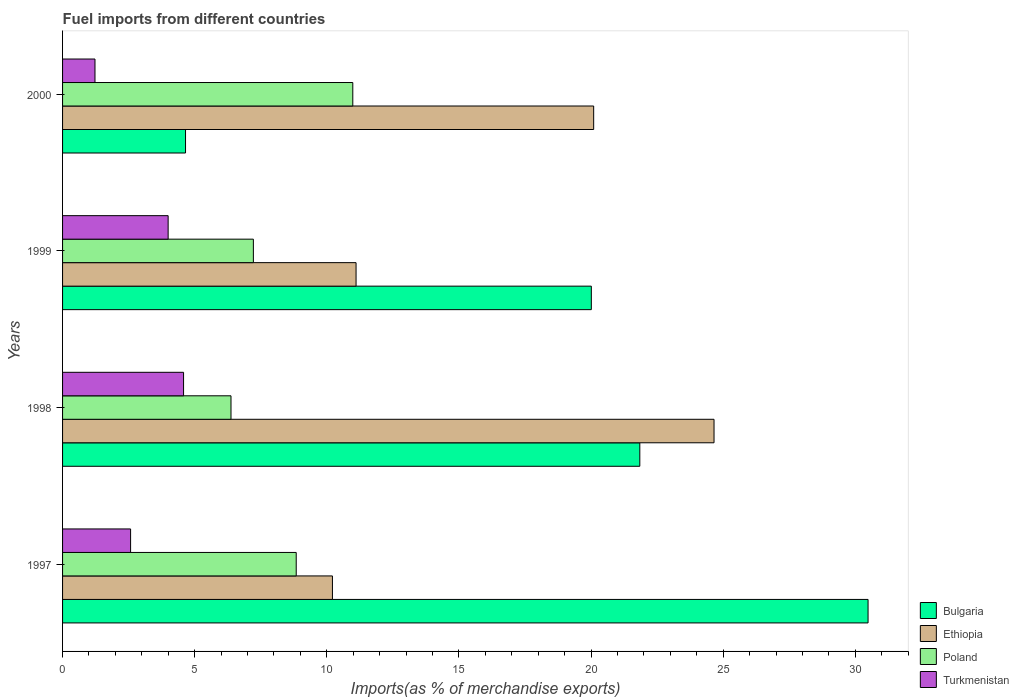How many different coloured bars are there?
Keep it short and to the point. 4. Are the number of bars on each tick of the Y-axis equal?
Offer a terse response. Yes. What is the label of the 3rd group of bars from the top?
Your answer should be compact. 1998. In how many cases, is the number of bars for a given year not equal to the number of legend labels?
Offer a terse response. 0. What is the percentage of imports to different countries in Bulgaria in 2000?
Your answer should be very brief. 4.65. Across all years, what is the maximum percentage of imports to different countries in Bulgaria?
Your answer should be compact. 30.48. Across all years, what is the minimum percentage of imports to different countries in Poland?
Provide a succinct answer. 6.37. In which year was the percentage of imports to different countries in Turkmenistan maximum?
Keep it short and to the point. 1998. What is the total percentage of imports to different countries in Poland in the graph?
Provide a short and direct response. 33.42. What is the difference between the percentage of imports to different countries in Bulgaria in 1997 and that in 1999?
Make the answer very short. 10.47. What is the difference between the percentage of imports to different countries in Ethiopia in 2000 and the percentage of imports to different countries in Poland in 1998?
Keep it short and to the point. 13.73. What is the average percentage of imports to different countries in Bulgaria per year?
Your response must be concise. 19.25. In the year 1999, what is the difference between the percentage of imports to different countries in Bulgaria and percentage of imports to different countries in Ethiopia?
Provide a succinct answer. 8.9. In how many years, is the percentage of imports to different countries in Turkmenistan greater than 18 %?
Provide a succinct answer. 0. What is the ratio of the percentage of imports to different countries in Ethiopia in 1998 to that in 1999?
Provide a succinct answer. 2.22. Is the percentage of imports to different countries in Poland in 1997 less than that in 2000?
Your answer should be compact. Yes. Is the difference between the percentage of imports to different countries in Bulgaria in 1997 and 2000 greater than the difference between the percentage of imports to different countries in Ethiopia in 1997 and 2000?
Give a very brief answer. Yes. What is the difference between the highest and the second highest percentage of imports to different countries in Ethiopia?
Your response must be concise. 4.55. What is the difference between the highest and the lowest percentage of imports to different countries in Bulgaria?
Offer a very short reply. 25.83. Is the sum of the percentage of imports to different countries in Ethiopia in 1997 and 1998 greater than the maximum percentage of imports to different countries in Turkmenistan across all years?
Ensure brevity in your answer.  Yes. Is it the case that in every year, the sum of the percentage of imports to different countries in Ethiopia and percentage of imports to different countries in Bulgaria is greater than the sum of percentage of imports to different countries in Turkmenistan and percentage of imports to different countries in Poland?
Offer a terse response. No. What does the 3rd bar from the top in 1998 represents?
Keep it short and to the point. Ethiopia. What does the 2nd bar from the bottom in 1997 represents?
Provide a short and direct response. Ethiopia. How many bars are there?
Provide a succinct answer. 16. Are all the bars in the graph horizontal?
Keep it short and to the point. Yes. How many years are there in the graph?
Your answer should be compact. 4. What is the difference between two consecutive major ticks on the X-axis?
Your response must be concise. 5. Are the values on the major ticks of X-axis written in scientific E-notation?
Your answer should be compact. No. Where does the legend appear in the graph?
Ensure brevity in your answer.  Bottom right. What is the title of the graph?
Your answer should be very brief. Fuel imports from different countries. What is the label or title of the X-axis?
Provide a succinct answer. Imports(as % of merchandise exports). What is the Imports(as % of merchandise exports) of Bulgaria in 1997?
Keep it short and to the point. 30.48. What is the Imports(as % of merchandise exports) in Ethiopia in 1997?
Keep it short and to the point. 10.21. What is the Imports(as % of merchandise exports) of Poland in 1997?
Provide a succinct answer. 8.84. What is the Imports(as % of merchandise exports) in Turkmenistan in 1997?
Your answer should be very brief. 2.57. What is the Imports(as % of merchandise exports) of Bulgaria in 1998?
Your answer should be very brief. 21.85. What is the Imports(as % of merchandise exports) of Ethiopia in 1998?
Give a very brief answer. 24.65. What is the Imports(as % of merchandise exports) in Poland in 1998?
Your response must be concise. 6.37. What is the Imports(as % of merchandise exports) of Turkmenistan in 1998?
Keep it short and to the point. 4.58. What is the Imports(as % of merchandise exports) in Bulgaria in 1999?
Your answer should be very brief. 20.01. What is the Imports(as % of merchandise exports) of Ethiopia in 1999?
Your answer should be very brief. 11.11. What is the Imports(as % of merchandise exports) of Poland in 1999?
Provide a succinct answer. 7.22. What is the Imports(as % of merchandise exports) in Turkmenistan in 1999?
Provide a succinct answer. 4. What is the Imports(as % of merchandise exports) in Bulgaria in 2000?
Provide a succinct answer. 4.65. What is the Imports(as % of merchandise exports) of Ethiopia in 2000?
Give a very brief answer. 20.1. What is the Imports(as % of merchandise exports) of Poland in 2000?
Your answer should be very brief. 10.98. What is the Imports(as % of merchandise exports) in Turkmenistan in 2000?
Keep it short and to the point. 1.23. Across all years, what is the maximum Imports(as % of merchandise exports) in Bulgaria?
Your answer should be very brief. 30.48. Across all years, what is the maximum Imports(as % of merchandise exports) of Ethiopia?
Provide a short and direct response. 24.65. Across all years, what is the maximum Imports(as % of merchandise exports) of Poland?
Provide a short and direct response. 10.98. Across all years, what is the maximum Imports(as % of merchandise exports) of Turkmenistan?
Your response must be concise. 4.58. Across all years, what is the minimum Imports(as % of merchandise exports) in Bulgaria?
Ensure brevity in your answer.  4.65. Across all years, what is the minimum Imports(as % of merchandise exports) of Ethiopia?
Provide a short and direct response. 10.21. Across all years, what is the minimum Imports(as % of merchandise exports) of Poland?
Give a very brief answer. 6.37. Across all years, what is the minimum Imports(as % of merchandise exports) in Turkmenistan?
Ensure brevity in your answer.  1.23. What is the total Imports(as % of merchandise exports) in Bulgaria in the graph?
Offer a very short reply. 76.99. What is the total Imports(as % of merchandise exports) in Ethiopia in the graph?
Give a very brief answer. 66.07. What is the total Imports(as % of merchandise exports) of Poland in the graph?
Keep it short and to the point. 33.42. What is the total Imports(as % of merchandise exports) of Turkmenistan in the graph?
Provide a succinct answer. 12.38. What is the difference between the Imports(as % of merchandise exports) of Bulgaria in 1997 and that in 1998?
Provide a succinct answer. 8.64. What is the difference between the Imports(as % of merchandise exports) of Ethiopia in 1997 and that in 1998?
Ensure brevity in your answer.  -14.44. What is the difference between the Imports(as % of merchandise exports) of Poland in 1997 and that in 1998?
Your answer should be compact. 2.47. What is the difference between the Imports(as % of merchandise exports) in Turkmenistan in 1997 and that in 1998?
Ensure brevity in your answer.  -2. What is the difference between the Imports(as % of merchandise exports) in Bulgaria in 1997 and that in 1999?
Give a very brief answer. 10.47. What is the difference between the Imports(as % of merchandise exports) of Ethiopia in 1997 and that in 1999?
Your answer should be compact. -0.89. What is the difference between the Imports(as % of merchandise exports) of Poland in 1997 and that in 1999?
Your response must be concise. 1.62. What is the difference between the Imports(as % of merchandise exports) in Turkmenistan in 1997 and that in 1999?
Offer a terse response. -1.42. What is the difference between the Imports(as % of merchandise exports) in Bulgaria in 1997 and that in 2000?
Offer a terse response. 25.83. What is the difference between the Imports(as % of merchandise exports) of Ethiopia in 1997 and that in 2000?
Offer a terse response. -9.89. What is the difference between the Imports(as % of merchandise exports) of Poland in 1997 and that in 2000?
Your response must be concise. -2.14. What is the difference between the Imports(as % of merchandise exports) in Turkmenistan in 1997 and that in 2000?
Offer a terse response. 1.35. What is the difference between the Imports(as % of merchandise exports) in Bulgaria in 1998 and that in 1999?
Your answer should be compact. 1.83. What is the difference between the Imports(as % of merchandise exports) of Ethiopia in 1998 and that in 1999?
Your answer should be compact. 13.55. What is the difference between the Imports(as % of merchandise exports) in Poland in 1998 and that in 1999?
Your answer should be very brief. -0.85. What is the difference between the Imports(as % of merchandise exports) in Turkmenistan in 1998 and that in 1999?
Keep it short and to the point. 0.58. What is the difference between the Imports(as % of merchandise exports) in Bulgaria in 1998 and that in 2000?
Give a very brief answer. 17.19. What is the difference between the Imports(as % of merchandise exports) of Ethiopia in 1998 and that in 2000?
Offer a terse response. 4.55. What is the difference between the Imports(as % of merchandise exports) in Poland in 1998 and that in 2000?
Offer a very short reply. -4.61. What is the difference between the Imports(as % of merchandise exports) of Turkmenistan in 1998 and that in 2000?
Offer a very short reply. 3.35. What is the difference between the Imports(as % of merchandise exports) in Bulgaria in 1999 and that in 2000?
Your answer should be compact. 15.36. What is the difference between the Imports(as % of merchandise exports) in Ethiopia in 1999 and that in 2000?
Provide a short and direct response. -8.99. What is the difference between the Imports(as % of merchandise exports) of Poland in 1999 and that in 2000?
Your answer should be very brief. -3.76. What is the difference between the Imports(as % of merchandise exports) of Turkmenistan in 1999 and that in 2000?
Keep it short and to the point. 2.77. What is the difference between the Imports(as % of merchandise exports) of Bulgaria in 1997 and the Imports(as % of merchandise exports) of Ethiopia in 1998?
Ensure brevity in your answer.  5.83. What is the difference between the Imports(as % of merchandise exports) of Bulgaria in 1997 and the Imports(as % of merchandise exports) of Poland in 1998?
Keep it short and to the point. 24.11. What is the difference between the Imports(as % of merchandise exports) in Bulgaria in 1997 and the Imports(as % of merchandise exports) in Turkmenistan in 1998?
Offer a very short reply. 25.9. What is the difference between the Imports(as % of merchandise exports) in Ethiopia in 1997 and the Imports(as % of merchandise exports) in Poland in 1998?
Give a very brief answer. 3.84. What is the difference between the Imports(as % of merchandise exports) in Ethiopia in 1997 and the Imports(as % of merchandise exports) in Turkmenistan in 1998?
Your response must be concise. 5.63. What is the difference between the Imports(as % of merchandise exports) in Poland in 1997 and the Imports(as % of merchandise exports) in Turkmenistan in 1998?
Give a very brief answer. 4.26. What is the difference between the Imports(as % of merchandise exports) in Bulgaria in 1997 and the Imports(as % of merchandise exports) in Ethiopia in 1999?
Provide a succinct answer. 19.38. What is the difference between the Imports(as % of merchandise exports) of Bulgaria in 1997 and the Imports(as % of merchandise exports) of Poland in 1999?
Provide a succinct answer. 23.26. What is the difference between the Imports(as % of merchandise exports) of Bulgaria in 1997 and the Imports(as % of merchandise exports) of Turkmenistan in 1999?
Offer a terse response. 26.49. What is the difference between the Imports(as % of merchandise exports) in Ethiopia in 1997 and the Imports(as % of merchandise exports) in Poland in 1999?
Offer a very short reply. 2.99. What is the difference between the Imports(as % of merchandise exports) in Ethiopia in 1997 and the Imports(as % of merchandise exports) in Turkmenistan in 1999?
Keep it short and to the point. 6.22. What is the difference between the Imports(as % of merchandise exports) of Poland in 1997 and the Imports(as % of merchandise exports) of Turkmenistan in 1999?
Offer a terse response. 4.85. What is the difference between the Imports(as % of merchandise exports) in Bulgaria in 1997 and the Imports(as % of merchandise exports) in Ethiopia in 2000?
Your answer should be very brief. 10.38. What is the difference between the Imports(as % of merchandise exports) in Bulgaria in 1997 and the Imports(as % of merchandise exports) in Poland in 2000?
Offer a very short reply. 19.5. What is the difference between the Imports(as % of merchandise exports) of Bulgaria in 1997 and the Imports(as % of merchandise exports) of Turkmenistan in 2000?
Your answer should be very brief. 29.26. What is the difference between the Imports(as % of merchandise exports) of Ethiopia in 1997 and the Imports(as % of merchandise exports) of Poland in 2000?
Ensure brevity in your answer.  -0.77. What is the difference between the Imports(as % of merchandise exports) in Ethiopia in 1997 and the Imports(as % of merchandise exports) in Turkmenistan in 2000?
Keep it short and to the point. 8.99. What is the difference between the Imports(as % of merchandise exports) of Poland in 1997 and the Imports(as % of merchandise exports) of Turkmenistan in 2000?
Offer a very short reply. 7.62. What is the difference between the Imports(as % of merchandise exports) in Bulgaria in 1998 and the Imports(as % of merchandise exports) in Ethiopia in 1999?
Keep it short and to the point. 10.74. What is the difference between the Imports(as % of merchandise exports) of Bulgaria in 1998 and the Imports(as % of merchandise exports) of Poland in 1999?
Your response must be concise. 14.62. What is the difference between the Imports(as % of merchandise exports) of Bulgaria in 1998 and the Imports(as % of merchandise exports) of Turkmenistan in 1999?
Provide a short and direct response. 17.85. What is the difference between the Imports(as % of merchandise exports) of Ethiopia in 1998 and the Imports(as % of merchandise exports) of Poland in 1999?
Offer a very short reply. 17.43. What is the difference between the Imports(as % of merchandise exports) in Ethiopia in 1998 and the Imports(as % of merchandise exports) in Turkmenistan in 1999?
Provide a succinct answer. 20.66. What is the difference between the Imports(as % of merchandise exports) of Poland in 1998 and the Imports(as % of merchandise exports) of Turkmenistan in 1999?
Your answer should be very brief. 2.38. What is the difference between the Imports(as % of merchandise exports) in Bulgaria in 1998 and the Imports(as % of merchandise exports) in Ethiopia in 2000?
Your response must be concise. 1.75. What is the difference between the Imports(as % of merchandise exports) of Bulgaria in 1998 and the Imports(as % of merchandise exports) of Poland in 2000?
Keep it short and to the point. 10.86. What is the difference between the Imports(as % of merchandise exports) in Bulgaria in 1998 and the Imports(as % of merchandise exports) in Turkmenistan in 2000?
Your answer should be very brief. 20.62. What is the difference between the Imports(as % of merchandise exports) in Ethiopia in 1998 and the Imports(as % of merchandise exports) in Poland in 2000?
Offer a very short reply. 13.67. What is the difference between the Imports(as % of merchandise exports) in Ethiopia in 1998 and the Imports(as % of merchandise exports) in Turkmenistan in 2000?
Offer a terse response. 23.43. What is the difference between the Imports(as % of merchandise exports) in Poland in 1998 and the Imports(as % of merchandise exports) in Turkmenistan in 2000?
Your answer should be compact. 5.15. What is the difference between the Imports(as % of merchandise exports) of Bulgaria in 1999 and the Imports(as % of merchandise exports) of Ethiopia in 2000?
Make the answer very short. -0.09. What is the difference between the Imports(as % of merchandise exports) in Bulgaria in 1999 and the Imports(as % of merchandise exports) in Poland in 2000?
Your answer should be compact. 9.03. What is the difference between the Imports(as % of merchandise exports) in Bulgaria in 1999 and the Imports(as % of merchandise exports) in Turkmenistan in 2000?
Make the answer very short. 18.78. What is the difference between the Imports(as % of merchandise exports) in Ethiopia in 1999 and the Imports(as % of merchandise exports) in Poland in 2000?
Your response must be concise. 0.12. What is the difference between the Imports(as % of merchandise exports) in Ethiopia in 1999 and the Imports(as % of merchandise exports) in Turkmenistan in 2000?
Make the answer very short. 9.88. What is the difference between the Imports(as % of merchandise exports) of Poland in 1999 and the Imports(as % of merchandise exports) of Turkmenistan in 2000?
Your answer should be compact. 5.99. What is the average Imports(as % of merchandise exports) in Bulgaria per year?
Offer a very short reply. 19.25. What is the average Imports(as % of merchandise exports) in Ethiopia per year?
Provide a succinct answer. 16.52. What is the average Imports(as % of merchandise exports) in Poland per year?
Provide a succinct answer. 8.36. What is the average Imports(as % of merchandise exports) of Turkmenistan per year?
Provide a succinct answer. 3.09. In the year 1997, what is the difference between the Imports(as % of merchandise exports) of Bulgaria and Imports(as % of merchandise exports) of Ethiopia?
Make the answer very short. 20.27. In the year 1997, what is the difference between the Imports(as % of merchandise exports) of Bulgaria and Imports(as % of merchandise exports) of Poland?
Ensure brevity in your answer.  21.64. In the year 1997, what is the difference between the Imports(as % of merchandise exports) of Bulgaria and Imports(as % of merchandise exports) of Turkmenistan?
Provide a short and direct response. 27.91. In the year 1997, what is the difference between the Imports(as % of merchandise exports) in Ethiopia and Imports(as % of merchandise exports) in Poland?
Provide a succinct answer. 1.37. In the year 1997, what is the difference between the Imports(as % of merchandise exports) in Ethiopia and Imports(as % of merchandise exports) in Turkmenistan?
Provide a succinct answer. 7.64. In the year 1997, what is the difference between the Imports(as % of merchandise exports) in Poland and Imports(as % of merchandise exports) in Turkmenistan?
Your answer should be very brief. 6.27. In the year 1998, what is the difference between the Imports(as % of merchandise exports) of Bulgaria and Imports(as % of merchandise exports) of Ethiopia?
Offer a very short reply. -2.81. In the year 1998, what is the difference between the Imports(as % of merchandise exports) of Bulgaria and Imports(as % of merchandise exports) of Poland?
Provide a short and direct response. 15.47. In the year 1998, what is the difference between the Imports(as % of merchandise exports) in Bulgaria and Imports(as % of merchandise exports) in Turkmenistan?
Give a very brief answer. 17.27. In the year 1998, what is the difference between the Imports(as % of merchandise exports) of Ethiopia and Imports(as % of merchandise exports) of Poland?
Give a very brief answer. 18.28. In the year 1998, what is the difference between the Imports(as % of merchandise exports) of Ethiopia and Imports(as % of merchandise exports) of Turkmenistan?
Your response must be concise. 20.08. In the year 1998, what is the difference between the Imports(as % of merchandise exports) of Poland and Imports(as % of merchandise exports) of Turkmenistan?
Keep it short and to the point. 1.8. In the year 1999, what is the difference between the Imports(as % of merchandise exports) of Bulgaria and Imports(as % of merchandise exports) of Ethiopia?
Provide a short and direct response. 8.9. In the year 1999, what is the difference between the Imports(as % of merchandise exports) in Bulgaria and Imports(as % of merchandise exports) in Poland?
Provide a succinct answer. 12.79. In the year 1999, what is the difference between the Imports(as % of merchandise exports) of Bulgaria and Imports(as % of merchandise exports) of Turkmenistan?
Offer a terse response. 16.02. In the year 1999, what is the difference between the Imports(as % of merchandise exports) in Ethiopia and Imports(as % of merchandise exports) in Poland?
Offer a very short reply. 3.89. In the year 1999, what is the difference between the Imports(as % of merchandise exports) of Ethiopia and Imports(as % of merchandise exports) of Turkmenistan?
Your response must be concise. 7.11. In the year 1999, what is the difference between the Imports(as % of merchandise exports) of Poland and Imports(as % of merchandise exports) of Turkmenistan?
Keep it short and to the point. 3.23. In the year 2000, what is the difference between the Imports(as % of merchandise exports) of Bulgaria and Imports(as % of merchandise exports) of Ethiopia?
Make the answer very short. -15.45. In the year 2000, what is the difference between the Imports(as % of merchandise exports) of Bulgaria and Imports(as % of merchandise exports) of Poland?
Your response must be concise. -6.33. In the year 2000, what is the difference between the Imports(as % of merchandise exports) in Bulgaria and Imports(as % of merchandise exports) in Turkmenistan?
Make the answer very short. 3.43. In the year 2000, what is the difference between the Imports(as % of merchandise exports) of Ethiopia and Imports(as % of merchandise exports) of Poland?
Your answer should be very brief. 9.12. In the year 2000, what is the difference between the Imports(as % of merchandise exports) in Ethiopia and Imports(as % of merchandise exports) in Turkmenistan?
Your answer should be compact. 18.87. In the year 2000, what is the difference between the Imports(as % of merchandise exports) in Poland and Imports(as % of merchandise exports) in Turkmenistan?
Offer a terse response. 9.76. What is the ratio of the Imports(as % of merchandise exports) in Bulgaria in 1997 to that in 1998?
Keep it short and to the point. 1.4. What is the ratio of the Imports(as % of merchandise exports) of Ethiopia in 1997 to that in 1998?
Your answer should be very brief. 0.41. What is the ratio of the Imports(as % of merchandise exports) in Poland in 1997 to that in 1998?
Your answer should be compact. 1.39. What is the ratio of the Imports(as % of merchandise exports) in Turkmenistan in 1997 to that in 1998?
Make the answer very short. 0.56. What is the ratio of the Imports(as % of merchandise exports) in Bulgaria in 1997 to that in 1999?
Keep it short and to the point. 1.52. What is the ratio of the Imports(as % of merchandise exports) of Ethiopia in 1997 to that in 1999?
Offer a terse response. 0.92. What is the ratio of the Imports(as % of merchandise exports) of Poland in 1997 to that in 1999?
Give a very brief answer. 1.22. What is the ratio of the Imports(as % of merchandise exports) of Turkmenistan in 1997 to that in 1999?
Your answer should be compact. 0.64. What is the ratio of the Imports(as % of merchandise exports) in Bulgaria in 1997 to that in 2000?
Your answer should be compact. 6.55. What is the ratio of the Imports(as % of merchandise exports) in Ethiopia in 1997 to that in 2000?
Your answer should be compact. 0.51. What is the ratio of the Imports(as % of merchandise exports) of Poland in 1997 to that in 2000?
Provide a short and direct response. 0.81. What is the ratio of the Imports(as % of merchandise exports) in Turkmenistan in 1997 to that in 2000?
Provide a short and direct response. 2.1. What is the ratio of the Imports(as % of merchandise exports) in Bulgaria in 1998 to that in 1999?
Keep it short and to the point. 1.09. What is the ratio of the Imports(as % of merchandise exports) in Ethiopia in 1998 to that in 1999?
Your response must be concise. 2.22. What is the ratio of the Imports(as % of merchandise exports) in Poland in 1998 to that in 1999?
Ensure brevity in your answer.  0.88. What is the ratio of the Imports(as % of merchandise exports) of Turkmenistan in 1998 to that in 1999?
Offer a very short reply. 1.15. What is the ratio of the Imports(as % of merchandise exports) in Bulgaria in 1998 to that in 2000?
Your answer should be very brief. 4.69. What is the ratio of the Imports(as % of merchandise exports) of Ethiopia in 1998 to that in 2000?
Your answer should be very brief. 1.23. What is the ratio of the Imports(as % of merchandise exports) of Poland in 1998 to that in 2000?
Your response must be concise. 0.58. What is the ratio of the Imports(as % of merchandise exports) in Turkmenistan in 1998 to that in 2000?
Ensure brevity in your answer.  3.73. What is the ratio of the Imports(as % of merchandise exports) in Bulgaria in 1999 to that in 2000?
Your response must be concise. 4.3. What is the ratio of the Imports(as % of merchandise exports) of Ethiopia in 1999 to that in 2000?
Offer a very short reply. 0.55. What is the ratio of the Imports(as % of merchandise exports) in Poland in 1999 to that in 2000?
Your answer should be very brief. 0.66. What is the ratio of the Imports(as % of merchandise exports) of Turkmenistan in 1999 to that in 2000?
Make the answer very short. 3.26. What is the difference between the highest and the second highest Imports(as % of merchandise exports) in Bulgaria?
Offer a very short reply. 8.64. What is the difference between the highest and the second highest Imports(as % of merchandise exports) of Ethiopia?
Ensure brevity in your answer.  4.55. What is the difference between the highest and the second highest Imports(as % of merchandise exports) of Poland?
Your response must be concise. 2.14. What is the difference between the highest and the second highest Imports(as % of merchandise exports) in Turkmenistan?
Your answer should be compact. 0.58. What is the difference between the highest and the lowest Imports(as % of merchandise exports) of Bulgaria?
Offer a very short reply. 25.83. What is the difference between the highest and the lowest Imports(as % of merchandise exports) of Ethiopia?
Your answer should be compact. 14.44. What is the difference between the highest and the lowest Imports(as % of merchandise exports) of Poland?
Your answer should be very brief. 4.61. What is the difference between the highest and the lowest Imports(as % of merchandise exports) in Turkmenistan?
Keep it short and to the point. 3.35. 